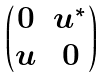<formula> <loc_0><loc_0><loc_500><loc_500>\begin{pmatrix} 0 & u ^ { \ast } \\ u & 0 \end{pmatrix}</formula> 